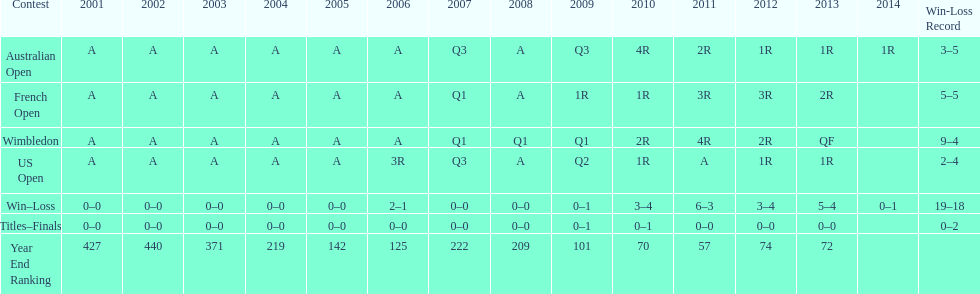What is the difference in wins between wimbledon and the us open for this player? 7. 